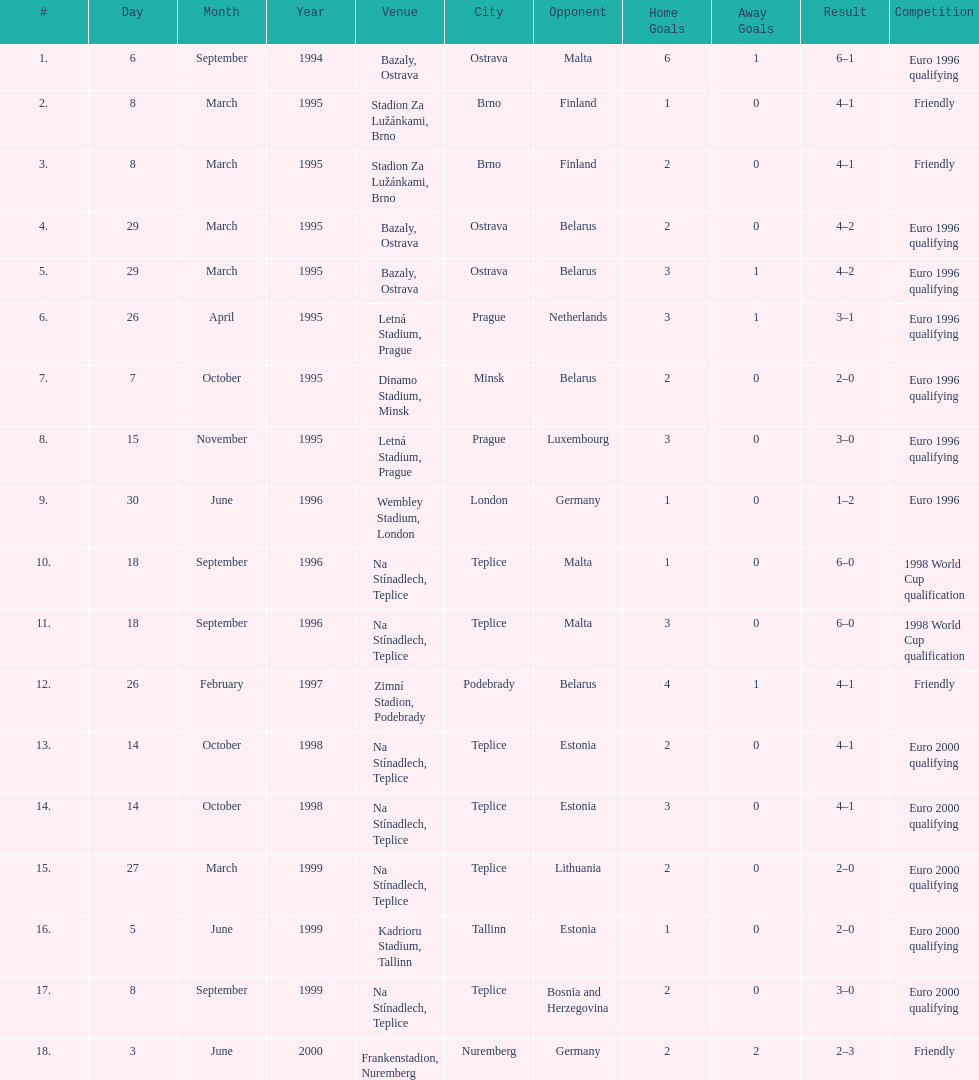Bazaly, ostrava was used on 6 september 1004, but what venue was used on 18 september 1996? Na Stínadlech, Teplice. 